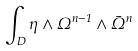Convert formula to latex. <formula><loc_0><loc_0><loc_500><loc_500>\int _ { D } \eta \wedge \Omega ^ { n - 1 } \wedge \bar { \Omega } ^ { n }</formula> 